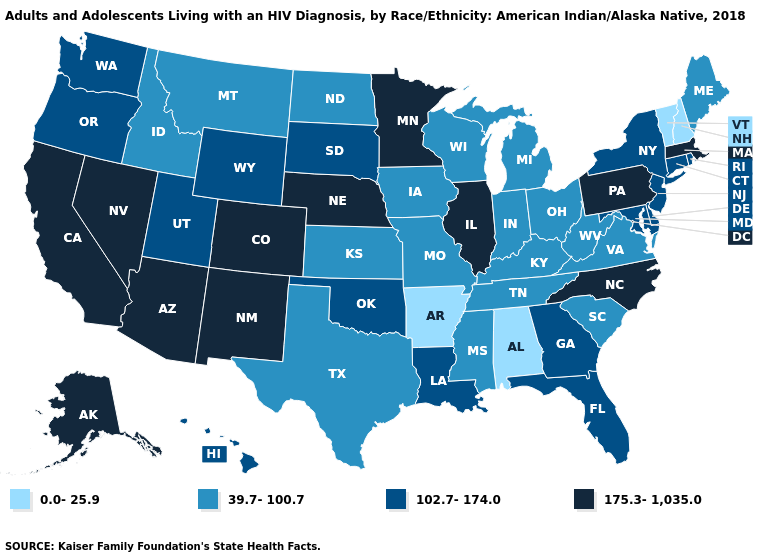What is the value of Missouri?
Keep it brief. 39.7-100.7. What is the value of Kentucky?
Quick response, please. 39.7-100.7. Does West Virginia have the highest value in the USA?
Write a very short answer. No. Does Alabama have the lowest value in the USA?
Answer briefly. Yes. Which states have the lowest value in the West?
Concise answer only. Idaho, Montana. Name the states that have a value in the range 102.7-174.0?
Keep it brief. Connecticut, Delaware, Florida, Georgia, Hawaii, Louisiana, Maryland, New Jersey, New York, Oklahoma, Oregon, Rhode Island, South Dakota, Utah, Washington, Wyoming. Does South Carolina have the same value as Kansas?
Concise answer only. Yes. What is the value of Kentucky?
Keep it brief. 39.7-100.7. Among the states that border California , which have the highest value?
Keep it brief. Arizona, Nevada. Name the states that have a value in the range 102.7-174.0?
Be succinct. Connecticut, Delaware, Florida, Georgia, Hawaii, Louisiana, Maryland, New Jersey, New York, Oklahoma, Oregon, Rhode Island, South Dakota, Utah, Washington, Wyoming. What is the lowest value in the South?
Write a very short answer. 0.0-25.9. Name the states that have a value in the range 0.0-25.9?
Give a very brief answer. Alabama, Arkansas, New Hampshire, Vermont. Name the states that have a value in the range 175.3-1,035.0?
Answer briefly. Alaska, Arizona, California, Colorado, Illinois, Massachusetts, Minnesota, Nebraska, Nevada, New Mexico, North Carolina, Pennsylvania. Does Illinois have the lowest value in the MidWest?
Write a very short answer. No. 